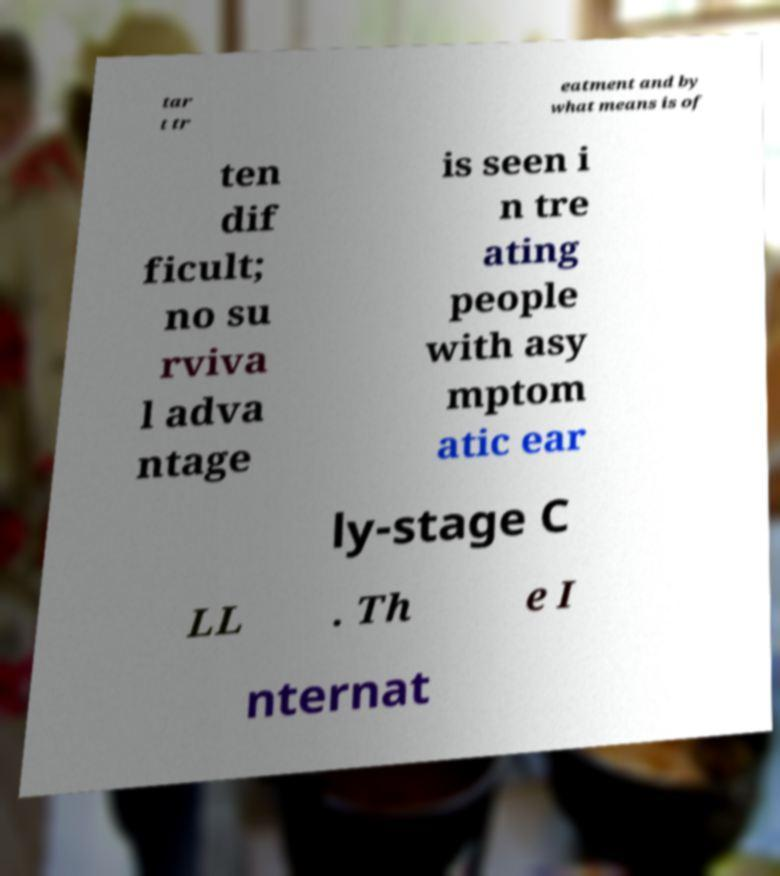Can you read and provide the text displayed in the image?This photo seems to have some interesting text. Can you extract and type it out for me? tar t tr eatment and by what means is of ten dif ficult; no su rviva l adva ntage is seen i n tre ating people with asy mptom atic ear ly-stage C LL . Th e I nternat 